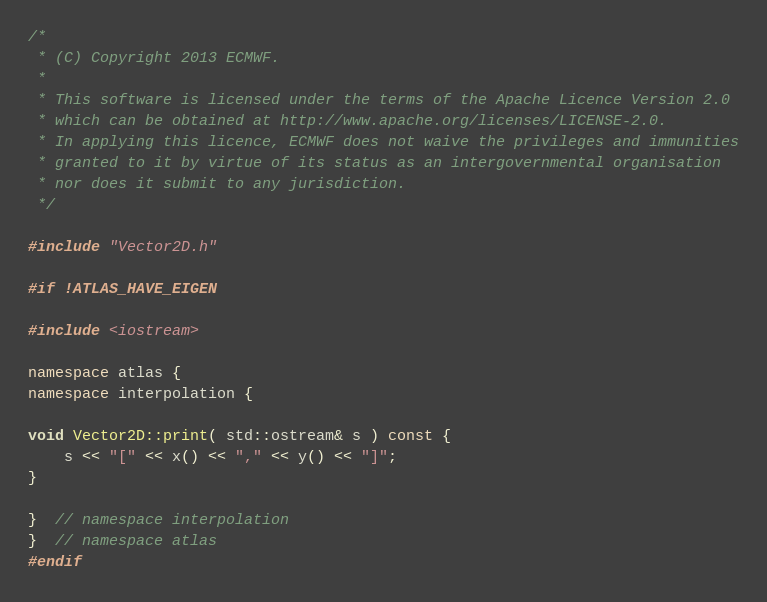Convert code to text. <code><loc_0><loc_0><loc_500><loc_500><_C++_>/*
 * (C) Copyright 2013 ECMWF.
 *
 * This software is licensed under the terms of the Apache Licence Version 2.0
 * which can be obtained at http://www.apache.org/licenses/LICENSE-2.0.
 * In applying this licence, ECMWF does not waive the privileges and immunities
 * granted to it by virtue of its status as an intergovernmental organisation
 * nor does it submit to any jurisdiction.
 */

#include "Vector2D.h"

#if !ATLAS_HAVE_EIGEN

#include <iostream>

namespace atlas {
namespace interpolation {

void Vector2D::print( std::ostream& s ) const {
    s << "[" << x() << "," << y() << "]";
}

}  // namespace interpolation
}  // namespace atlas
#endif
</code> 